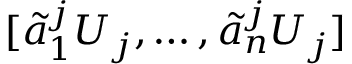<formula> <loc_0><loc_0><loc_500><loc_500>[ \tilde { a } _ { 1 } ^ { j } U _ { j } , \dots , \tilde { a } _ { n } ^ { j } U _ { j } ]</formula> 